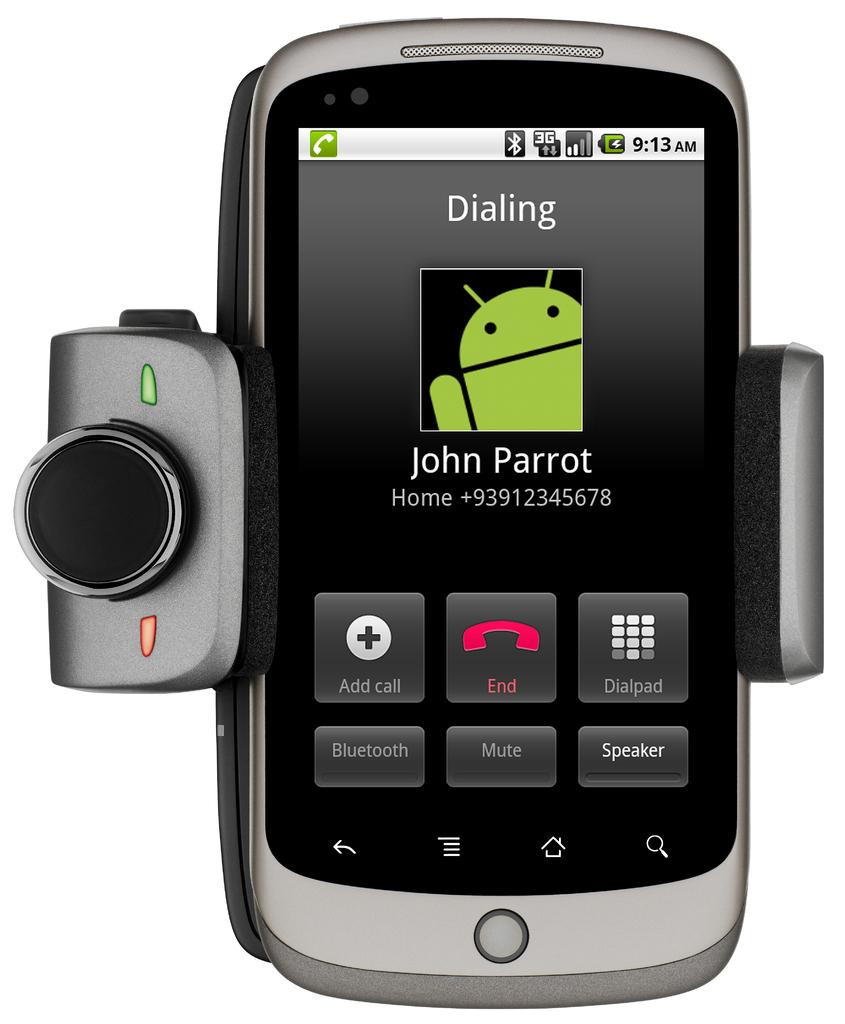<image>
Write a terse but informative summary of the picture. a cell phone making a call to John Parrot at home 